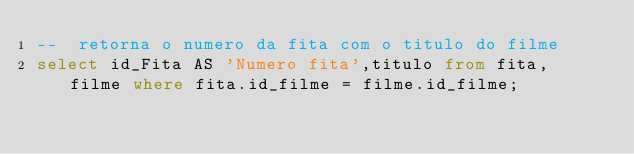<code> <loc_0><loc_0><loc_500><loc_500><_SQL_>--  retorna o numero da fita com o titulo do filme
select id_Fita AS 'Numero fita',titulo from fita, filme where fita.id_filme = filme.id_filme;

</code> 